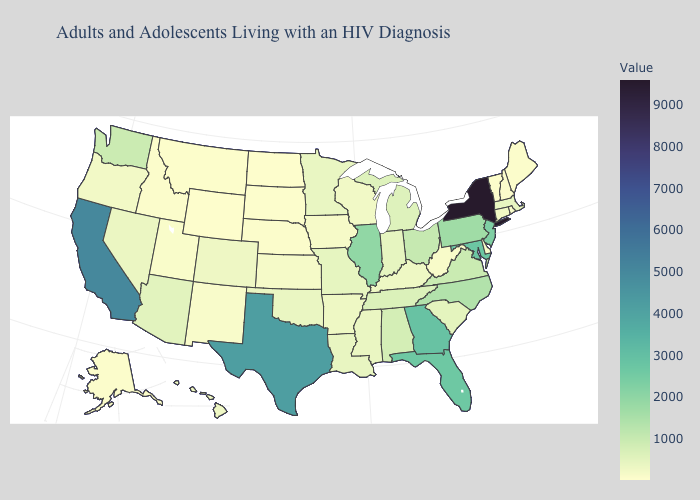Among the states that border North Dakota , does Minnesota have the lowest value?
Quick response, please. No. Does Oregon have a lower value than Maryland?
Answer briefly. Yes. Among the states that border Massachusetts , which have the highest value?
Keep it brief. New York. Which states hav the highest value in the West?
Short answer required. California. Does the map have missing data?
Quick response, please. No. Among the states that border Georgia , does South Carolina have the highest value?
Concise answer only. No. Which states have the lowest value in the USA?
Answer briefly. Wyoming. Which states have the lowest value in the USA?
Keep it brief. Wyoming. 